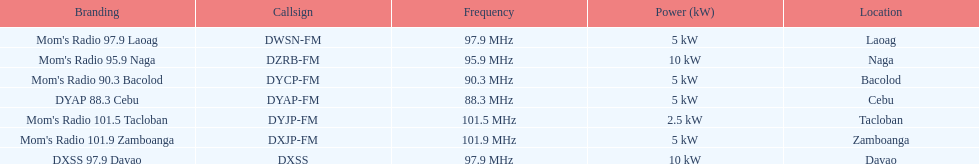How many kw was the radio in davao? 10 kW. Can you parse all the data within this table? {'header': ['Branding', 'Callsign', 'Frequency', 'Power (kW)', 'Location'], 'rows': [["Mom's Radio 97.9 Laoag", 'DWSN-FM', '97.9\xa0MHz', '5\xa0kW', 'Laoag'], ["Mom's Radio 95.9 Naga", 'DZRB-FM', '95.9\xa0MHz', '10\xa0kW', 'Naga'], ["Mom's Radio 90.3 Bacolod", 'DYCP-FM', '90.3\xa0MHz', '5\xa0kW', 'Bacolod'], ['DYAP 88.3 Cebu', 'DYAP-FM', '88.3\xa0MHz', '5\xa0kW', 'Cebu'], ["Mom's Radio 101.5 Tacloban", 'DYJP-FM', '101.5\xa0MHz', '2.5\xa0kW', 'Tacloban'], ["Mom's Radio 101.9 Zamboanga", 'DXJP-FM', '101.9\xa0MHz', '5\xa0kW', 'Zamboanga'], ['DXSS 97.9 Davao', 'DXSS', '97.9\xa0MHz', '10\xa0kW', 'Davao']]} 